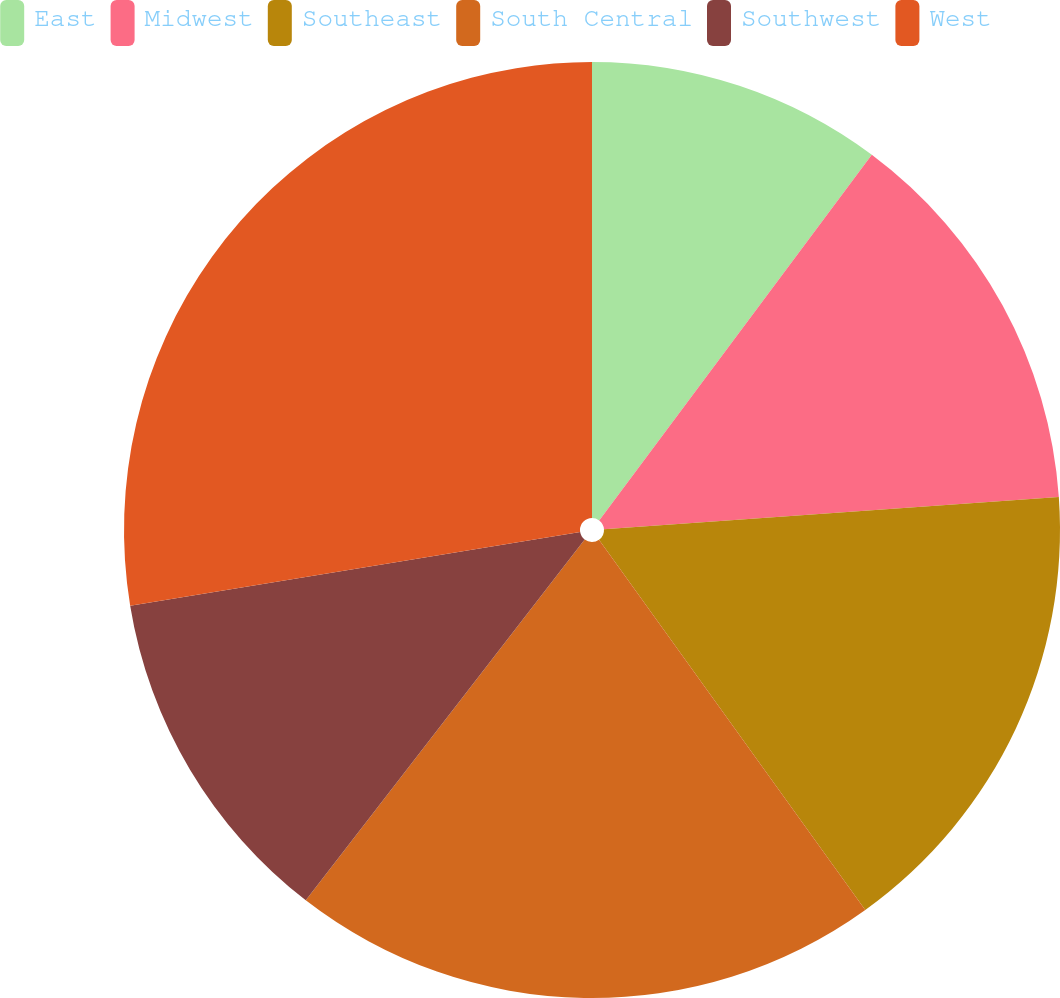Convert chart. <chart><loc_0><loc_0><loc_500><loc_500><pie_chart><fcel>East<fcel>Midwest<fcel>Southeast<fcel>South Central<fcel>Southwest<fcel>West<nl><fcel>10.2%<fcel>13.68%<fcel>16.2%<fcel>20.4%<fcel>11.94%<fcel>27.59%<nl></chart> 